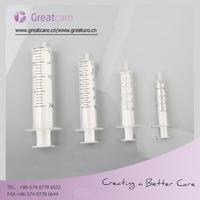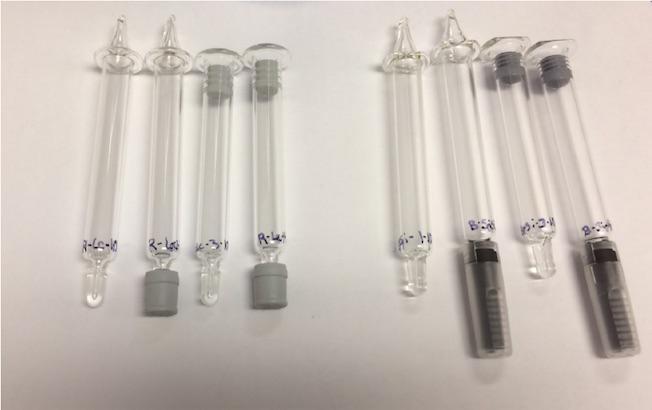The first image is the image on the left, the second image is the image on the right. Assess this claim about the two images: "At least one image shows a horizontal row of syringes arranged in order of size.". Correct or not? Answer yes or no. Yes. The first image is the image on the left, the second image is the image on the right. Given the left and right images, does the statement "There are eight syringes in total." hold true? Answer yes or no. No. 